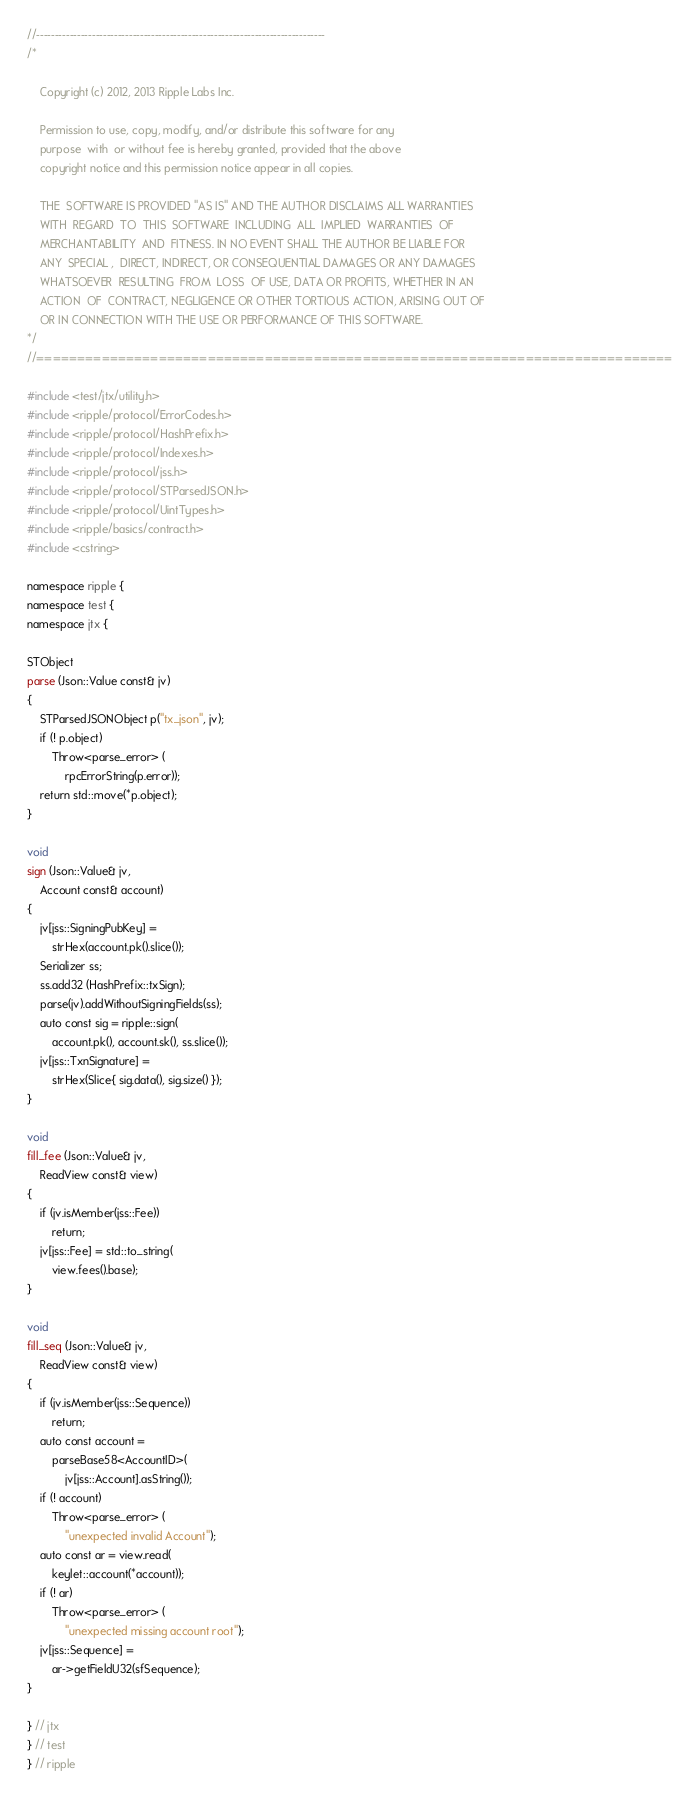Convert code to text. <code><loc_0><loc_0><loc_500><loc_500><_C++_>//------------------------------------------------------------------------------
/*
    
    Copyright (c) 2012, 2013 Ripple Labs Inc.

    Permission to use, copy, modify, and/or distribute this software for any
    purpose  with  or without fee is hereby granted, provided that the above
    copyright notice and this permission notice appear in all copies.

    THE  SOFTWARE IS PROVIDED "AS IS" AND THE AUTHOR DISCLAIMS ALL WARRANTIES
    WITH  REGARD  TO  THIS  SOFTWARE  INCLUDING  ALL  IMPLIED  WARRANTIES  OF
    MERCHANTABILITY  AND  FITNESS. IN NO EVENT SHALL THE AUTHOR BE LIABLE FOR
    ANY  SPECIAL ,  DIRECT, INDIRECT, OR CONSEQUENTIAL DAMAGES OR ANY DAMAGES
    WHATSOEVER  RESULTING  FROM  LOSS  OF USE, DATA OR PROFITS, WHETHER IN AN
    ACTION  OF  CONTRACT, NEGLIGENCE OR OTHER TORTIOUS ACTION, ARISING OUT OF
    OR IN CONNECTION WITH THE USE OR PERFORMANCE OF THIS SOFTWARE.
*/
//==============================================================================

#include <test/jtx/utility.h>
#include <ripple/protocol/ErrorCodes.h>
#include <ripple/protocol/HashPrefix.h>
#include <ripple/protocol/Indexes.h>
#include <ripple/protocol/jss.h>
#include <ripple/protocol/STParsedJSON.h>
#include <ripple/protocol/UintTypes.h>
#include <ripple/basics/contract.h>
#include <cstring>

namespace ripple {
namespace test {
namespace jtx {

STObject
parse (Json::Value const& jv)
{
    STParsedJSONObject p("tx_json", jv);
    if (! p.object)
        Throw<parse_error> (
            rpcErrorString(p.error));
    return std::move(*p.object);
}

void
sign (Json::Value& jv,
    Account const& account)
{
    jv[jss::SigningPubKey] =
        strHex(account.pk().slice());
    Serializer ss;
    ss.add32 (HashPrefix::txSign);
    parse(jv).addWithoutSigningFields(ss);
    auto const sig = ripple::sign(
        account.pk(), account.sk(), ss.slice());
    jv[jss::TxnSignature] =
        strHex(Slice{ sig.data(), sig.size() });
}

void
fill_fee (Json::Value& jv,
    ReadView const& view)
{
    if (jv.isMember(jss::Fee))
        return;
    jv[jss::Fee] = std::to_string(
        view.fees().base);
}

void
fill_seq (Json::Value& jv,
    ReadView const& view)
{
    if (jv.isMember(jss::Sequence))
        return;
    auto const account =
        parseBase58<AccountID>(
            jv[jss::Account].asString());
    if (! account)
        Throw<parse_error> (
            "unexpected invalid Account");
    auto const ar = view.read(
        keylet::account(*account));
    if (! ar)
        Throw<parse_error> (
            "unexpected missing account root");
    jv[jss::Sequence] =
        ar->getFieldU32(sfSequence);
}

} // jtx
} // test
} // ripple
</code> 